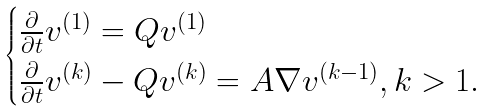Convert formula to latex. <formula><loc_0><loc_0><loc_500><loc_500>\begin{cases} \frac { \partial } { \partial t } { v } ^ { ( 1 ) } = Q { v } ^ { ( 1 ) } \\ \frac { \partial } { \partial t } { v } ^ { ( k ) } - Q { v } ^ { ( k ) } = A \nabla { v } ^ { ( k - 1 ) } , k > 1 . \end{cases}</formula> 